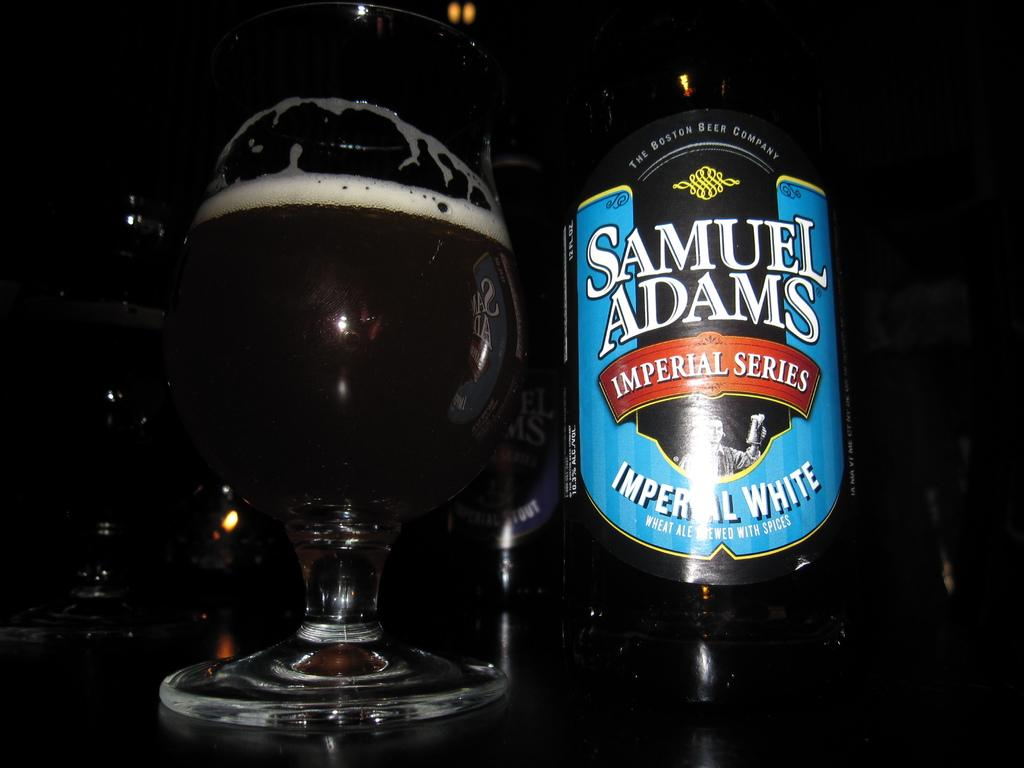<image>
Offer a succinct explanation of the picture presented. A glass of beer next to the beer bottle that says Samuel Adams Imperial Series 